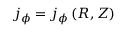Convert formula to latex. <formula><loc_0><loc_0><loc_500><loc_500>j _ { \phi } = j _ { \phi } \left ( R , Z \right )</formula> 